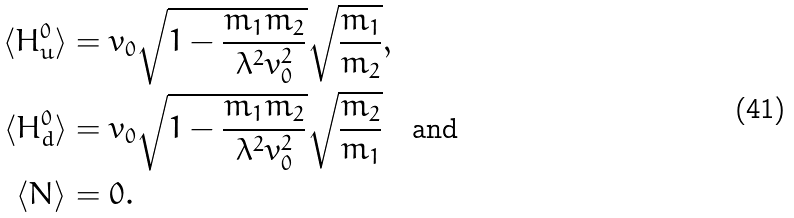Convert formula to latex. <formula><loc_0><loc_0><loc_500><loc_500>\langle H _ { u } ^ { 0 } \rangle & = v _ { 0 } \sqrt { 1 - \frac { m _ { 1 } m _ { 2 } } { \lambda ^ { 2 } v _ { 0 } ^ { 2 } } } \sqrt { \frac { m _ { 1 } } { m _ { 2 } } } , \\ \langle H _ { d } ^ { 0 } \rangle & = v _ { 0 } \sqrt { 1 - \frac { m _ { 1 } m _ { 2 } } { \lambda ^ { 2 } v _ { 0 } ^ { 2 } } } \sqrt { \frac { m _ { 2 } } { m _ { 1 } } } \quad \text {and} \\ \langle N \rangle & = 0 .</formula> 